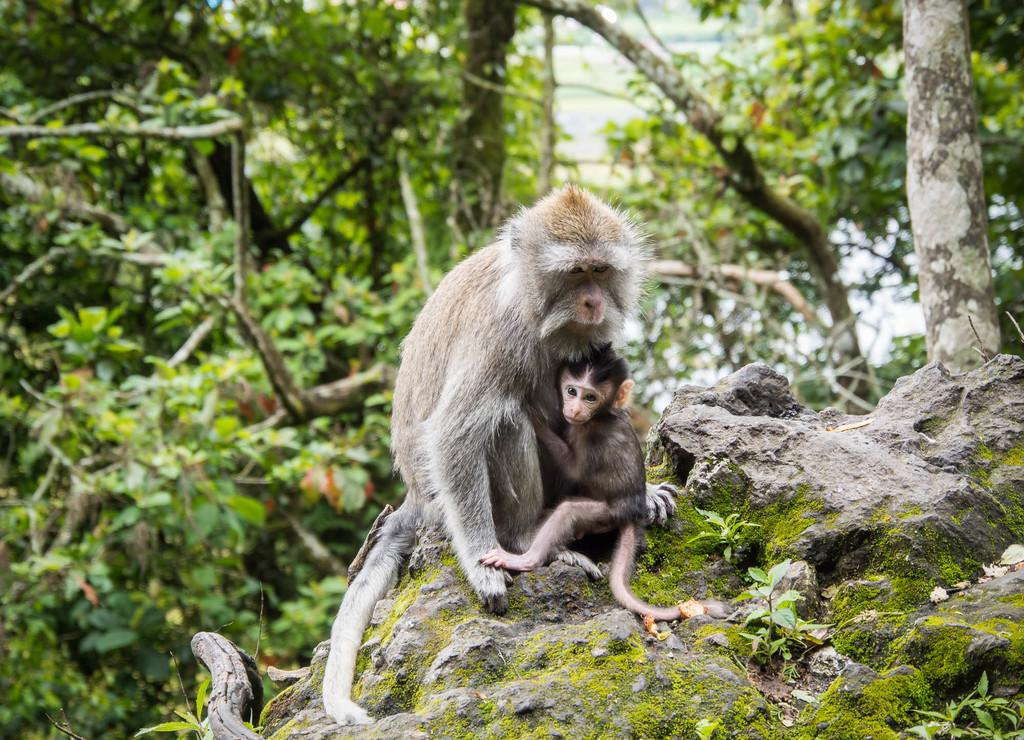How many monkeys are present in the image? There are two monkeys in the image. What can be seen in the background of the image? There are trees in the background of the image. What type of magic is being performed by the monkeys in the image? There is no magic being performed by the monkeys in the image; they are simply present in the scene. 